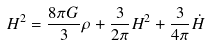<formula> <loc_0><loc_0><loc_500><loc_500>H ^ { 2 } = \frac { 8 \pi G } { 3 } \rho + \frac { 3 } { 2 \pi } H ^ { 2 } + \frac { 3 } { 4 \pi } \dot { H }</formula> 